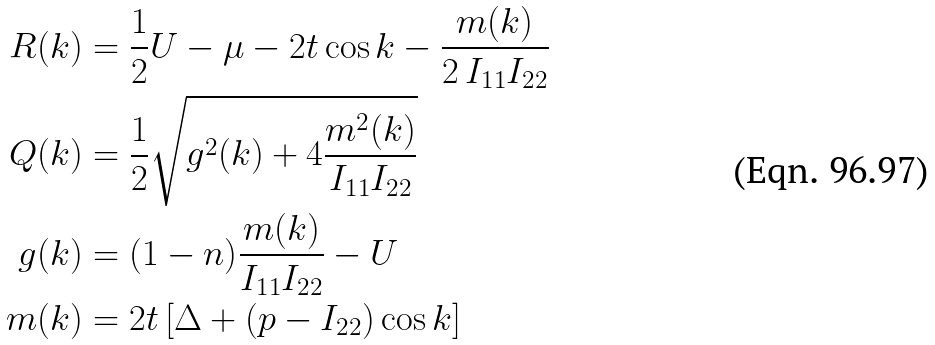Convert formula to latex. <formula><loc_0><loc_0><loc_500><loc_500>R ( k ) & = \frac { 1 } { 2 } U - \mu - 2 t \cos k - \frac { m ( k ) } { 2 \, I _ { 1 1 } I _ { 2 2 } } \\ Q ( k ) & = \frac { 1 } { 2 } \sqrt { g ^ { 2 } ( k ) + 4 \frac { m ^ { 2 } ( k ) } { I _ { 1 1 } I _ { 2 2 } } } \\ g ( k ) & = ( 1 - n ) \frac { m ( k ) } { I _ { 1 1 } I _ { 2 2 } } - U \\ m ( k ) & = 2 t \left [ \Delta + \left ( p - I _ { 2 2 } \right ) \cos k \right ]</formula> 